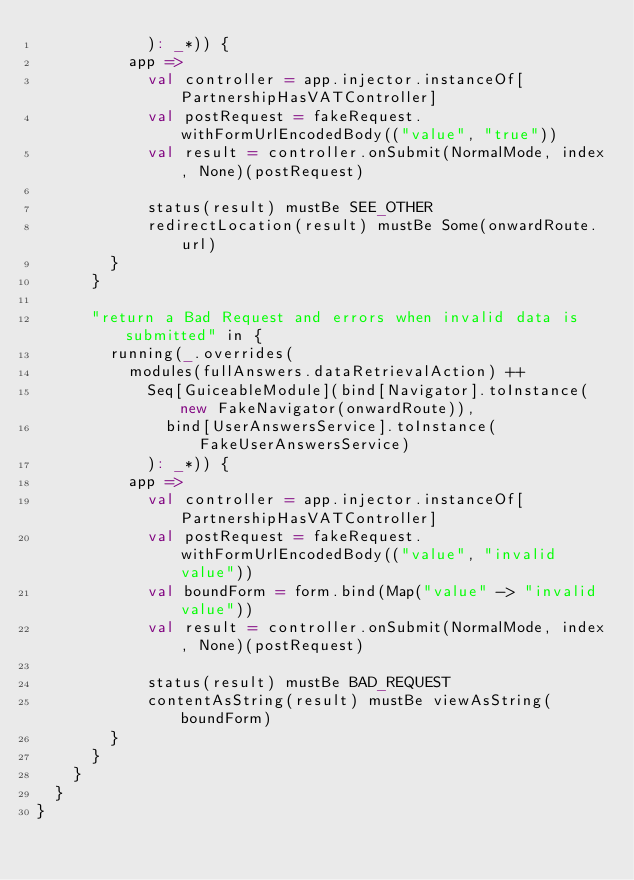Convert code to text. <code><loc_0><loc_0><loc_500><loc_500><_Scala_>            ): _*)) {
          app =>
            val controller = app.injector.instanceOf[PartnershipHasVATController]
            val postRequest = fakeRequest.withFormUrlEncodedBody(("value", "true"))
            val result = controller.onSubmit(NormalMode, index, None)(postRequest)

            status(result) mustBe SEE_OTHER
            redirectLocation(result) mustBe Some(onwardRoute.url)
        }
      }

      "return a Bad Request and errors when invalid data is submitted" in {
        running(_.overrides(
          modules(fullAnswers.dataRetrievalAction) ++
            Seq[GuiceableModule](bind[Navigator].toInstance(new FakeNavigator(onwardRoute)),
              bind[UserAnswersService].toInstance(FakeUserAnswersService)
            ): _*)) {
          app =>
            val controller = app.injector.instanceOf[PartnershipHasVATController]
            val postRequest = fakeRequest.withFormUrlEncodedBody(("value", "invalid value"))
            val boundForm = form.bind(Map("value" -> "invalid value"))
            val result = controller.onSubmit(NormalMode, index, None)(postRequest)

            status(result) mustBe BAD_REQUEST
            contentAsString(result) mustBe viewAsString(boundForm)
        }
      }
    }
  }
}
</code> 